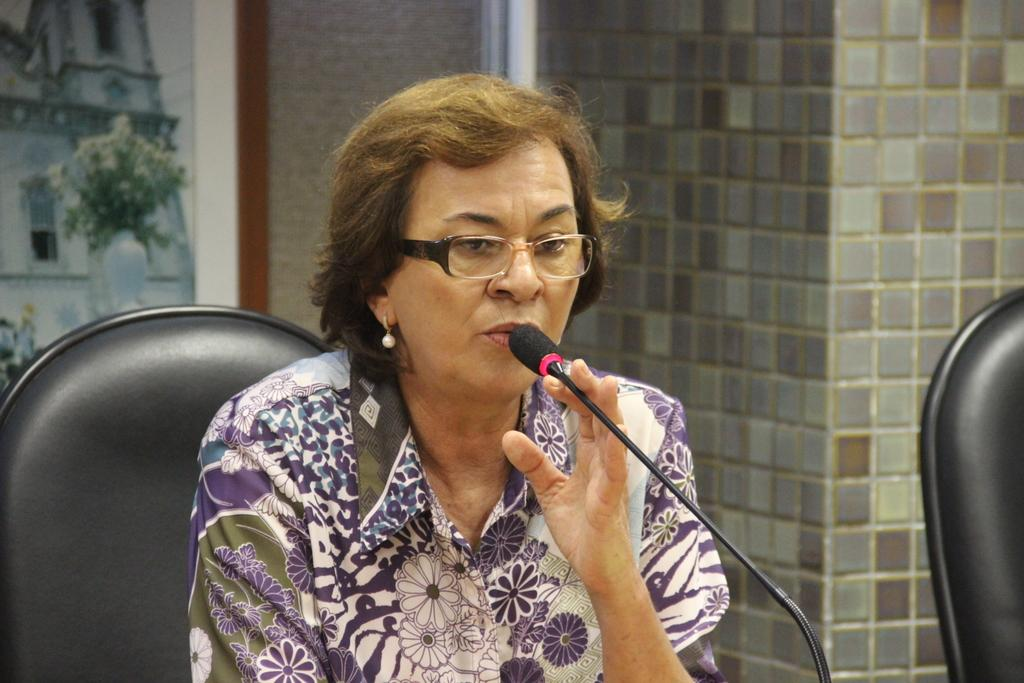Who is the main subject in the image? There is a woman in the image. What is the woman doing in the image? The woman is sitting on a chair and talking. What is the woman holding in the image? The woman is holding a microphone. Is there another chair in the image? Yes, there is another chair beside the woman. What can be seen in the background of the image? There is a wall in the background of the image, and there is a frame on the wall. What type of decision can be seen hanging from the frame on the wall? There is no decision present in the image; it features a woman sitting on a chair, holding a microphone, and talking. 